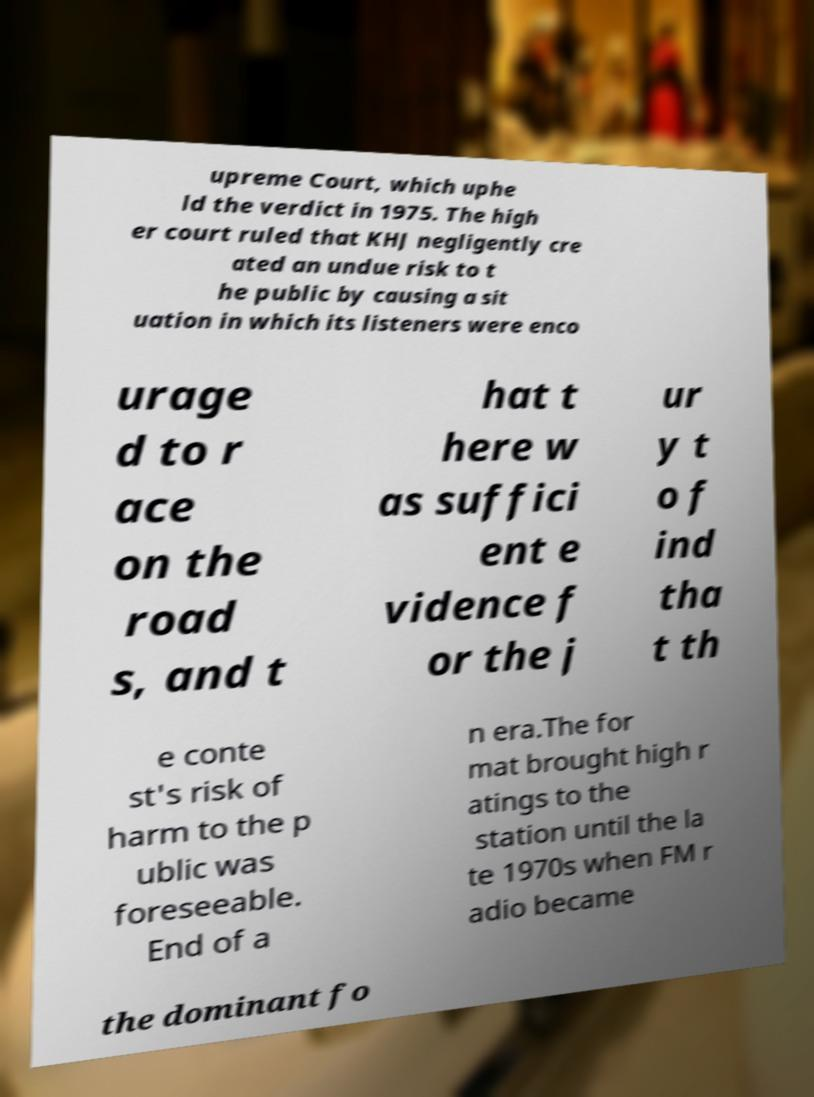For documentation purposes, I need the text within this image transcribed. Could you provide that? upreme Court, which uphe ld the verdict in 1975. The high er court ruled that KHJ negligently cre ated an undue risk to t he public by causing a sit uation in which its listeners were enco urage d to r ace on the road s, and t hat t here w as suffici ent e vidence f or the j ur y t o f ind tha t th e conte st's risk of harm to the p ublic was foreseeable. End of a n era.The for mat brought high r atings to the station until the la te 1970s when FM r adio became the dominant fo 